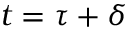<formula> <loc_0><loc_0><loc_500><loc_500>t = \tau + \delta</formula> 